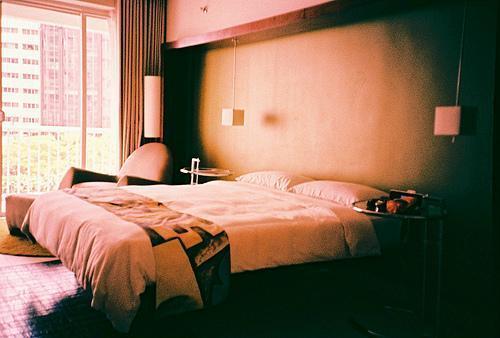How many beds are in the picture?
Give a very brief answer. 1. How many pillows are on the bed?
Give a very brief answer. 2. 